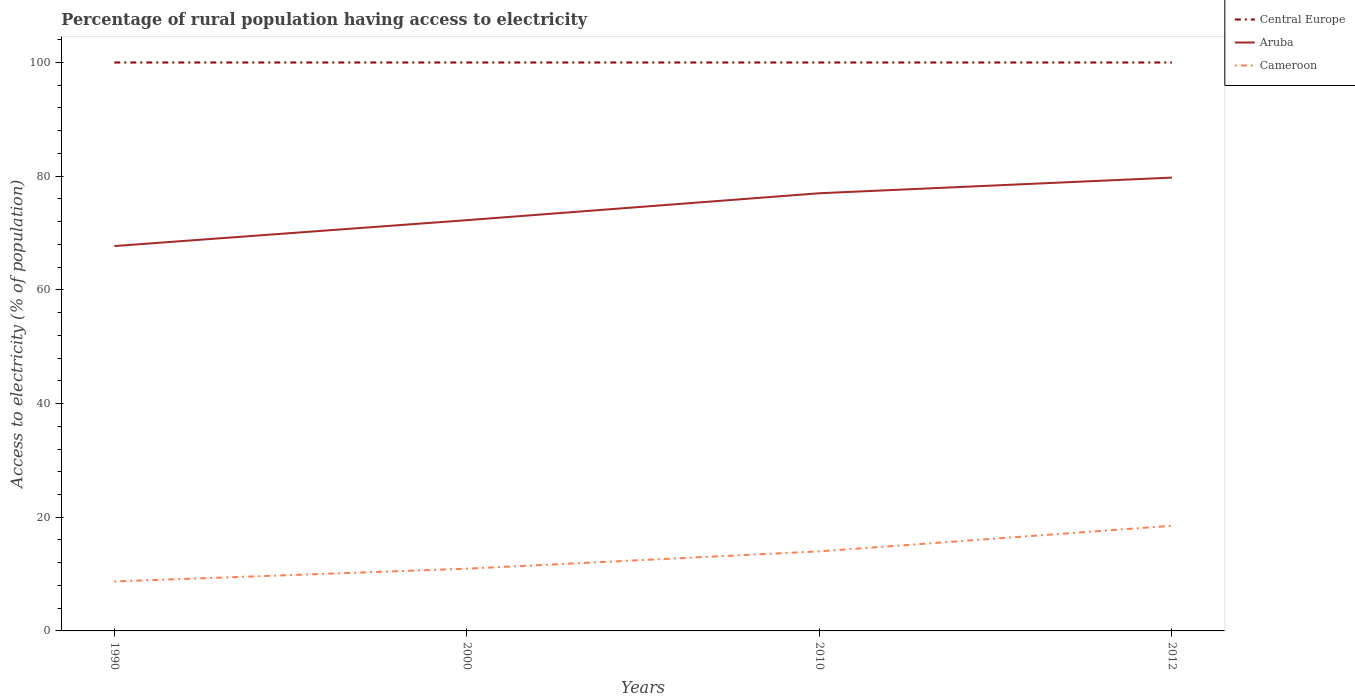How many different coloured lines are there?
Provide a succinct answer. 3. Is the number of lines equal to the number of legend labels?
Your answer should be compact. Yes. In which year was the percentage of rural population having access to electricity in Central Europe maximum?
Your response must be concise. 1990. What is the total percentage of rural population having access to electricity in Central Europe in the graph?
Your answer should be very brief. 0. What is the difference between the highest and the second highest percentage of rural population having access to electricity in Aruba?
Provide a succinct answer. 12.04. Is the percentage of rural population having access to electricity in Central Europe strictly greater than the percentage of rural population having access to electricity in Cameroon over the years?
Offer a very short reply. No. How many lines are there?
Your answer should be compact. 3. How many years are there in the graph?
Your response must be concise. 4. What is the difference between two consecutive major ticks on the Y-axis?
Ensure brevity in your answer.  20. Are the values on the major ticks of Y-axis written in scientific E-notation?
Your answer should be very brief. No. Where does the legend appear in the graph?
Offer a very short reply. Top right. What is the title of the graph?
Offer a very short reply. Percentage of rural population having access to electricity. Does "Burundi" appear as one of the legend labels in the graph?
Your response must be concise. No. What is the label or title of the Y-axis?
Your answer should be compact. Access to electricity (% of population). What is the Access to electricity (% of population) in Central Europe in 1990?
Offer a terse response. 100. What is the Access to electricity (% of population) of Aruba in 1990?
Ensure brevity in your answer.  67.71. What is the Access to electricity (% of population) in Cameroon in 1990?
Your answer should be compact. 8.7. What is the Access to electricity (% of population) in Central Europe in 2000?
Your answer should be very brief. 100. What is the Access to electricity (% of population) in Aruba in 2000?
Give a very brief answer. 72.27. What is the Access to electricity (% of population) of Cameroon in 2000?
Offer a very short reply. 10.95. What is the Access to electricity (% of population) of Central Europe in 2010?
Make the answer very short. 100. What is the Access to electricity (% of population) of Cameroon in 2010?
Offer a very short reply. 14. What is the Access to electricity (% of population) in Aruba in 2012?
Make the answer very short. 79.75. What is the Access to electricity (% of population) of Cameroon in 2012?
Offer a very short reply. 18.5. Across all years, what is the maximum Access to electricity (% of population) in Central Europe?
Give a very brief answer. 100. Across all years, what is the maximum Access to electricity (% of population) in Aruba?
Offer a terse response. 79.75. Across all years, what is the maximum Access to electricity (% of population) in Cameroon?
Your response must be concise. 18.5. Across all years, what is the minimum Access to electricity (% of population) of Aruba?
Offer a very short reply. 67.71. Across all years, what is the minimum Access to electricity (% of population) of Cameroon?
Make the answer very short. 8.7. What is the total Access to electricity (% of population) of Central Europe in the graph?
Keep it short and to the point. 400. What is the total Access to electricity (% of population) in Aruba in the graph?
Offer a very short reply. 296.73. What is the total Access to electricity (% of population) in Cameroon in the graph?
Offer a very short reply. 52.15. What is the difference between the Access to electricity (% of population) in Central Europe in 1990 and that in 2000?
Offer a terse response. 0. What is the difference between the Access to electricity (% of population) in Aruba in 1990 and that in 2000?
Keep it short and to the point. -4.55. What is the difference between the Access to electricity (% of population) in Cameroon in 1990 and that in 2000?
Keep it short and to the point. -2.25. What is the difference between the Access to electricity (% of population) of Central Europe in 1990 and that in 2010?
Your answer should be compact. 0. What is the difference between the Access to electricity (% of population) of Aruba in 1990 and that in 2010?
Give a very brief answer. -9.29. What is the difference between the Access to electricity (% of population) of Cameroon in 1990 and that in 2010?
Your answer should be very brief. -5.3. What is the difference between the Access to electricity (% of population) of Aruba in 1990 and that in 2012?
Make the answer very short. -12.04. What is the difference between the Access to electricity (% of population) of Cameroon in 1990 and that in 2012?
Ensure brevity in your answer.  -9.8. What is the difference between the Access to electricity (% of population) of Central Europe in 2000 and that in 2010?
Give a very brief answer. 0. What is the difference between the Access to electricity (% of population) of Aruba in 2000 and that in 2010?
Ensure brevity in your answer.  -4.74. What is the difference between the Access to electricity (% of population) in Cameroon in 2000 and that in 2010?
Your answer should be very brief. -3.05. What is the difference between the Access to electricity (% of population) in Aruba in 2000 and that in 2012?
Offer a terse response. -7.49. What is the difference between the Access to electricity (% of population) of Cameroon in 2000 and that in 2012?
Make the answer very short. -7.55. What is the difference between the Access to electricity (% of population) of Central Europe in 2010 and that in 2012?
Keep it short and to the point. 0. What is the difference between the Access to electricity (% of population) of Aruba in 2010 and that in 2012?
Provide a short and direct response. -2.75. What is the difference between the Access to electricity (% of population) of Cameroon in 2010 and that in 2012?
Provide a succinct answer. -4.5. What is the difference between the Access to electricity (% of population) in Central Europe in 1990 and the Access to electricity (% of population) in Aruba in 2000?
Your answer should be very brief. 27.73. What is the difference between the Access to electricity (% of population) in Central Europe in 1990 and the Access to electricity (% of population) in Cameroon in 2000?
Make the answer very short. 89.05. What is the difference between the Access to electricity (% of population) of Aruba in 1990 and the Access to electricity (% of population) of Cameroon in 2000?
Keep it short and to the point. 56.76. What is the difference between the Access to electricity (% of population) of Central Europe in 1990 and the Access to electricity (% of population) of Aruba in 2010?
Your answer should be very brief. 23. What is the difference between the Access to electricity (% of population) of Aruba in 1990 and the Access to electricity (% of population) of Cameroon in 2010?
Give a very brief answer. 53.71. What is the difference between the Access to electricity (% of population) in Central Europe in 1990 and the Access to electricity (% of population) in Aruba in 2012?
Provide a short and direct response. 20.25. What is the difference between the Access to electricity (% of population) in Central Europe in 1990 and the Access to electricity (% of population) in Cameroon in 2012?
Provide a short and direct response. 81.5. What is the difference between the Access to electricity (% of population) in Aruba in 1990 and the Access to electricity (% of population) in Cameroon in 2012?
Your response must be concise. 49.21. What is the difference between the Access to electricity (% of population) of Central Europe in 2000 and the Access to electricity (% of population) of Cameroon in 2010?
Offer a very short reply. 86. What is the difference between the Access to electricity (% of population) in Aruba in 2000 and the Access to electricity (% of population) in Cameroon in 2010?
Keep it short and to the point. 58.27. What is the difference between the Access to electricity (% of population) of Central Europe in 2000 and the Access to electricity (% of population) of Aruba in 2012?
Your answer should be very brief. 20.25. What is the difference between the Access to electricity (% of population) of Central Europe in 2000 and the Access to electricity (% of population) of Cameroon in 2012?
Make the answer very short. 81.5. What is the difference between the Access to electricity (% of population) of Aruba in 2000 and the Access to electricity (% of population) of Cameroon in 2012?
Keep it short and to the point. 53.77. What is the difference between the Access to electricity (% of population) in Central Europe in 2010 and the Access to electricity (% of population) in Aruba in 2012?
Keep it short and to the point. 20.25. What is the difference between the Access to electricity (% of population) in Central Europe in 2010 and the Access to electricity (% of population) in Cameroon in 2012?
Offer a terse response. 81.5. What is the difference between the Access to electricity (% of population) of Aruba in 2010 and the Access to electricity (% of population) of Cameroon in 2012?
Your answer should be compact. 58.5. What is the average Access to electricity (% of population) in Central Europe per year?
Your answer should be compact. 100. What is the average Access to electricity (% of population) in Aruba per year?
Offer a very short reply. 74.18. What is the average Access to electricity (% of population) in Cameroon per year?
Provide a succinct answer. 13.04. In the year 1990, what is the difference between the Access to electricity (% of population) of Central Europe and Access to electricity (% of population) of Aruba?
Make the answer very short. 32.29. In the year 1990, what is the difference between the Access to electricity (% of population) in Central Europe and Access to electricity (% of population) in Cameroon?
Your answer should be very brief. 91.3. In the year 1990, what is the difference between the Access to electricity (% of population) in Aruba and Access to electricity (% of population) in Cameroon?
Your answer should be compact. 59.01. In the year 2000, what is the difference between the Access to electricity (% of population) of Central Europe and Access to electricity (% of population) of Aruba?
Offer a terse response. 27.73. In the year 2000, what is the difference between the Access to electricity (% of population) in Central Europe and Access to electricity (% of population) in Cameroon?
Offer a terse response. 89.05. In the year 2000, what is the difference between the Access to electricity (% of population) in Aruba and Access to electricity (% of population) in Cameroon?
Keep it short and to the point. 61.31. In the year 2010, what is the difference between the Access to electricity (% of population) in Central Europe and Access to electricity (% of population) in Aruba?
Your answer should be very brief. 23. In the year 2010, what is the difference between the Access to electricity (% of population) in Central Europe and Access to electricity (% of population) in Cameroon?
Your response must be concise. 86. In the year 2010, what is the difference between the Access to electricity (% of population) in Aruba and Access to electricity (% of population) in Cameroon?
Provide a short and direct response. 63. In the year 2012, what is the difference between the Access to electricity (% of population) of Central Europe and Access to electricity (% of population) of Aruba?
Make the answer very short. 20.25. In the year 2012, what is the difference between the Access to electricity (% of population) in Central Europe and Access to electricity (% of population) in Cameroon?
Ensure brevity in your answer.  81.5. In the year 2012, what is the difference between the Access to electricity (% of population) of Aruba and Access to electricity (% of population) of Cameroon?
Your answer should be very brief. 61.25. What is the ratio of the Access to electricity (% of population) in Aruba in 1990 to that in 2000?
Ensure brevity in your answer.  0.94. What is the ratio of the Access to electricity (% of population) of Cameroon in 1990 to that in 2000?
Give a very brief answer. 0.79. What is the ratio of the Access to electricity (% of population) of Central Europe in 1990 to that in 2010?
Offer a terse response. 1. What is the ratio of the Access to electricity (% of population) in Aruba in 1990 to that in 2010?
Keep it short and to the point. 0.88. What is the ratio of the Access to electricity (% of population) in Cameroon in 1990 to that in 2010?
Give a very brief answer. 0.62. What is the ratio of the Access to electricity (% of population) of Central Europe in 1990 to that in 2012?
Your answer should be very brief. 1. What is the ratio of the Access to electricity (% of population) of Aruba in 1990 to that in 2012?
Ensure brevity in your answer.  0.85. What is the ratio of the Access to electricity (% of population) of Cameroon in 1990 to that in 2012?
Offer a very short reply. 0.47. What is the ratio of the Access to electricity (% of population) of Central Europe in 2000 to that in 2010?
Offer a terse response. 1. What is the ratio of the Access to electricity (% of population) of Aruba in 2000 to that in 2010?
Provide a short and direct response. 0.94. What is the ratio of the Access to electricity (% of population) in Cameroon in 2000 to that in 2010?
Your answer should be very brief. 0.78. What is the ratio of the Access to electricity (% of population) of Aruba in 2000 to that in 2012?
Ensure brevity in your answer.  0.91. What is the ratio of the Access to electricity (% of population) of Cameroon in 2000 to that in 2012?
Offer a very short reply. 0.59. What is the ratio of the Access to electricity (% of population) of Aruba in 2010 to that in 2012?
Provide a short and direct response. 0.97. What is the ratio of the Access to electricity (% of population) in Cameroon in 2010 to that in 2012?
Your response must be concise. 0.76. What is the difference between the highest and the second highest Access to electricity (% of population) in Aruba?
Make the answer very short. 2.75. What is the difference between the highest and the second highest Access to electricity (% of population) of Cameroon?
Give a very brief answer. 4.5. What is the difference between the highest and the lowest Access to electricity (% of population) of Aruba?
Offer a very short reply. 12.04. What is the difference between the highest and the lowest Access to electricity (% of population) in Cameroon?
Ensure brevity in your answer.  9.8. 